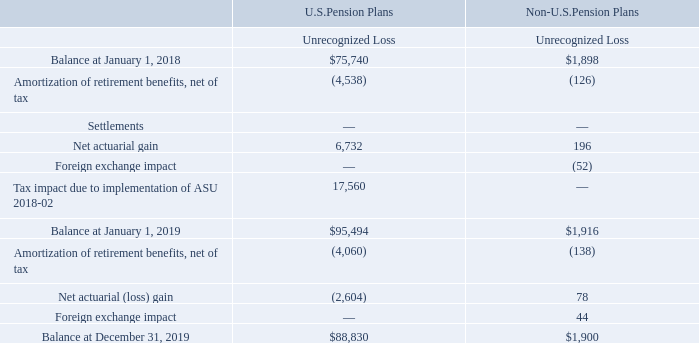NOTES TO CONSOLIDATED FINANCIAL STATEMENTS (in thousands, except for share and per share data)
We have also recorded the following amounts to accumulated other comprehensive loss for the U.S. and non-U.S. pension plans, net of tax:
What was the balance of Unrecognized loss for U.S. Pension Plans in 2018?
Answer scale should be: thousand. 75,740. What was the unrecognized loss for Net actuarial gain for Non-U.S. Pension Plans?
Answer scale should be: thousand. 196. What was the balance of Amortization of retirement benefits, net of tax for Non-U.S. Pension Plans?
Answer scale should be: thousand. (138). What was the difference in the balance at December 31, 2019 for Unrecognized losses between U.S and Non-U.S. Pension Plans?
Answer scale should be: thousand. 88,830-1,900
Answer: 86930. What was the difference between the Amortization of retirement benefits, net of tax between U.S. and Non-U.S. Pension Plans in 2019?
Answer scale should be: thousand. -4,060-(-138)
Answer: -3922. What was the percentage change in the balance for unrecognized losses for U.S. Pension Plans between January 1, 2018 and 2019?
Answer scale should be: percent. (95,494-75,740)/75,740
Answer: 26.08. 